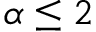<formula> <loc_0><loc_0><loc_500><loc_500>\alpha \leq 2</formula> 